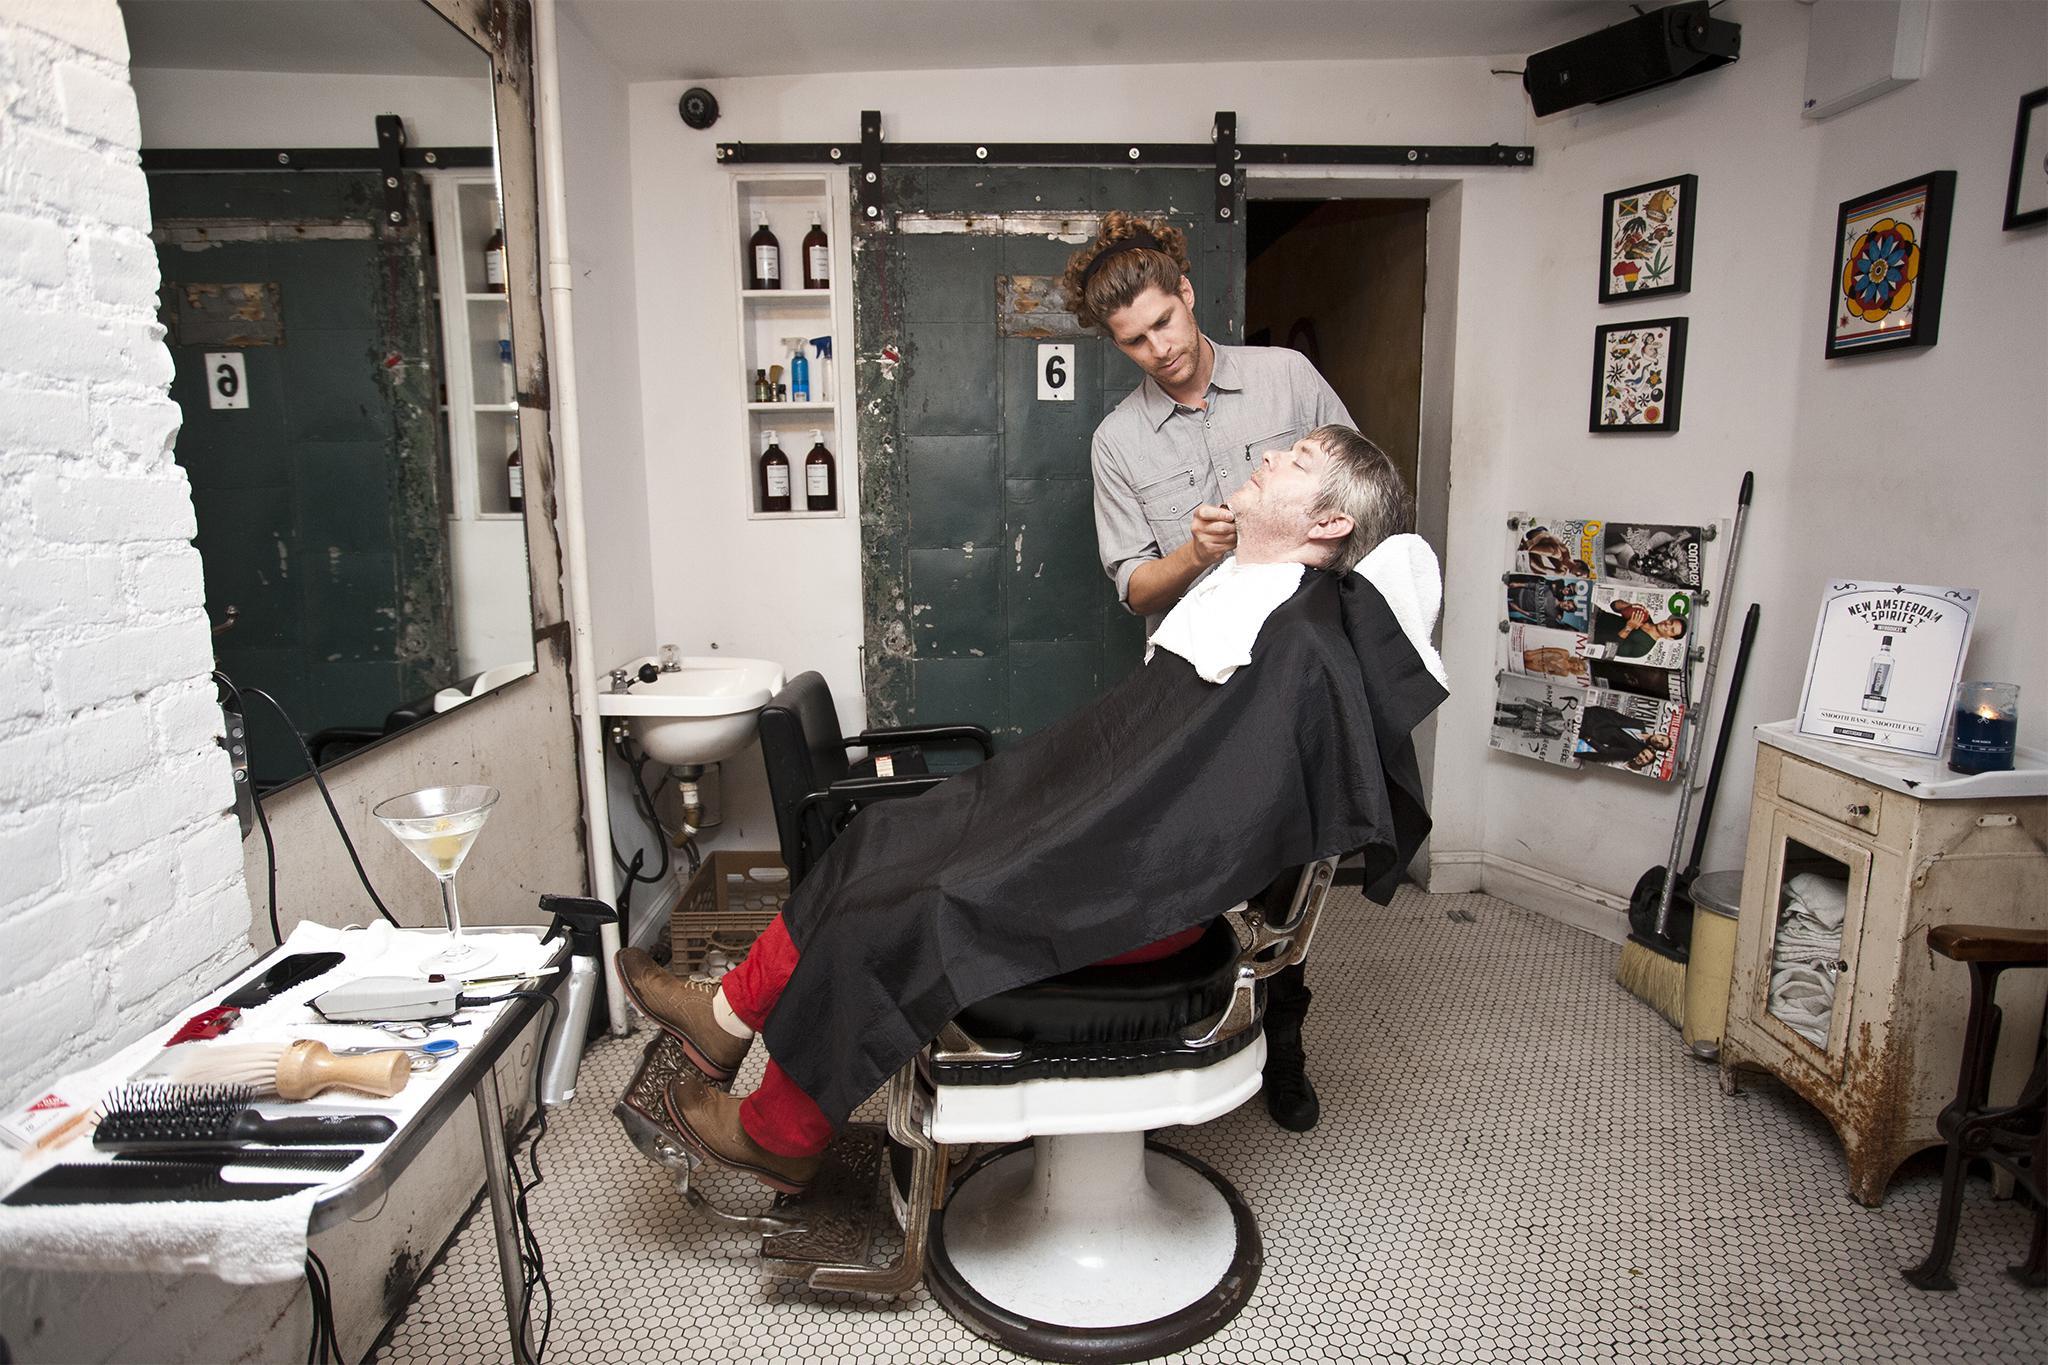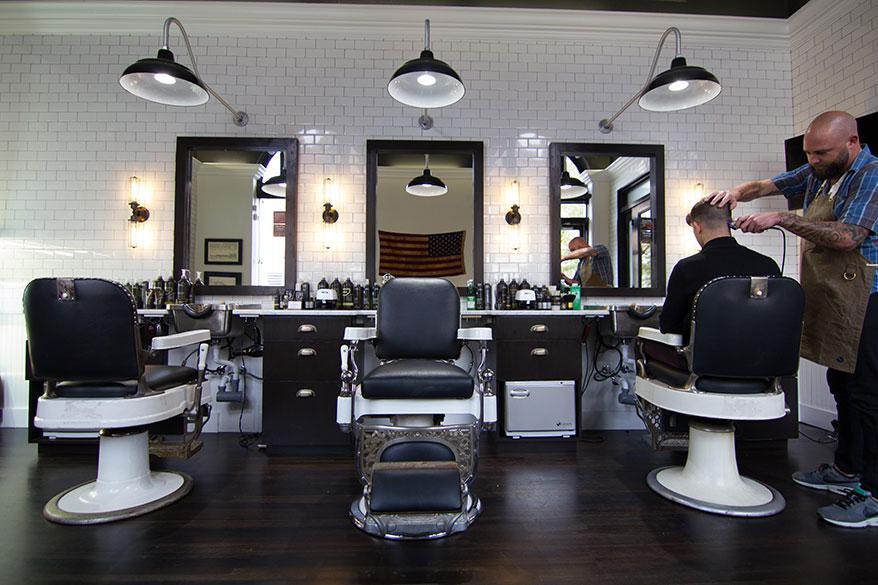The first image is the image on the left, the second image is the image on the right. Assess this claim about the two images: "In at least one of the images within a set, the barber is only cutting one person's hair, in the left most chair.". Correct or not? Answer yes or no. Yes. The first image is the image on the left, the second image is the image on the right. Given the left and right images, does the statement "There is at least one male barber in a black shirt cutting the hair of a man in a cape sitting in the barber chair." hold true? Answer yes or no. No. 